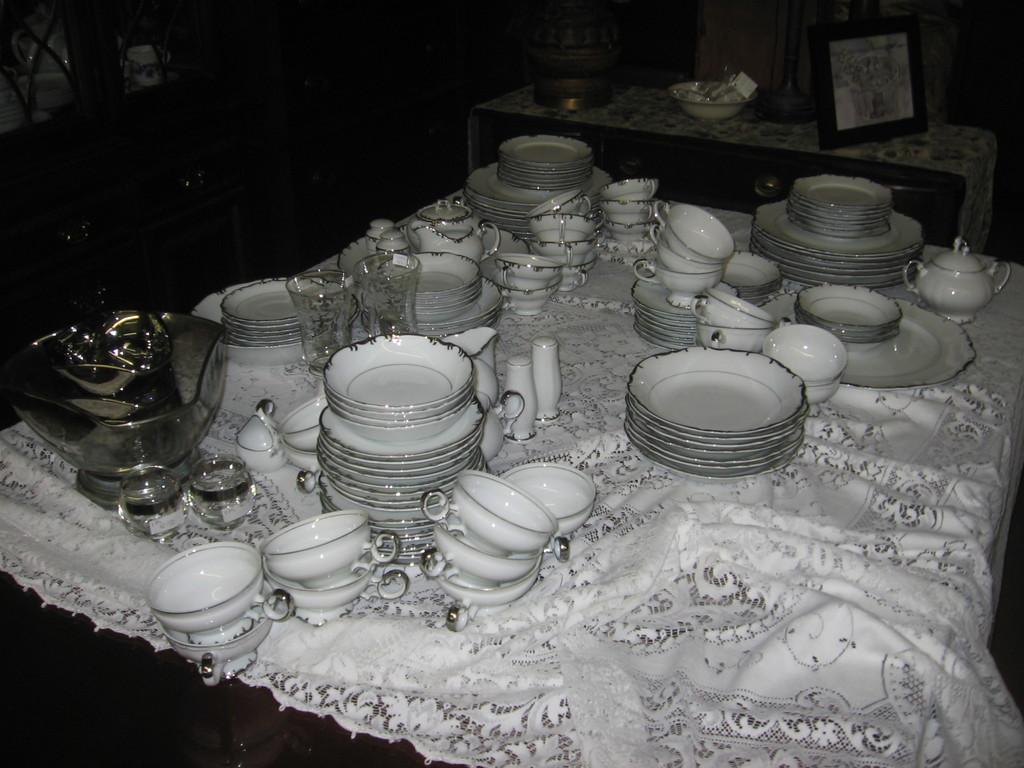Can you describe this image briefly? In this picture we can observe some plates, bowls and a teapot placed on the white color cloth. All the dishes were in white color. We can observe glasses on this cloth. There is a desk on which we can observe a photo frame. The background is dark. 